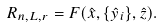Convert formula to latex. <formula><loc_0><loc_0><loc_500><loc_500>R _ { n , L , r } = F ( \hat { x } , \{ \hat { y } _ { i } \} , \hat { z } ) .</formula> 